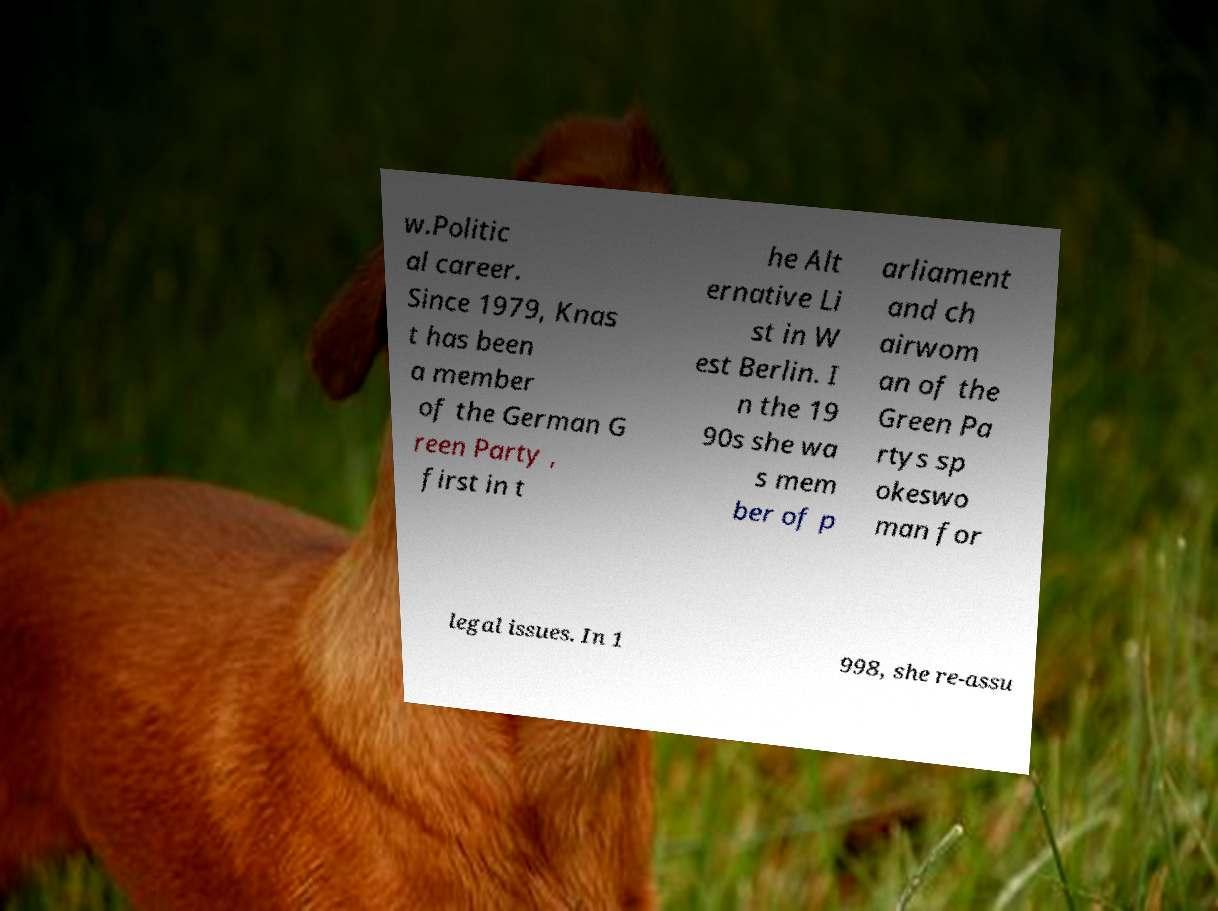Could you extract and type out the text from this image? w.Politic al career. Since 1979, Knas t has been a member of the German G reen Party , first in t he Alt ernative Li st in W est Berlin. I n the 19 90s she wa s mem ber of p arliament and ch airwom an of the Green Pa rtys sp okeswo man for legal issues. In 1 998, she re-assu 